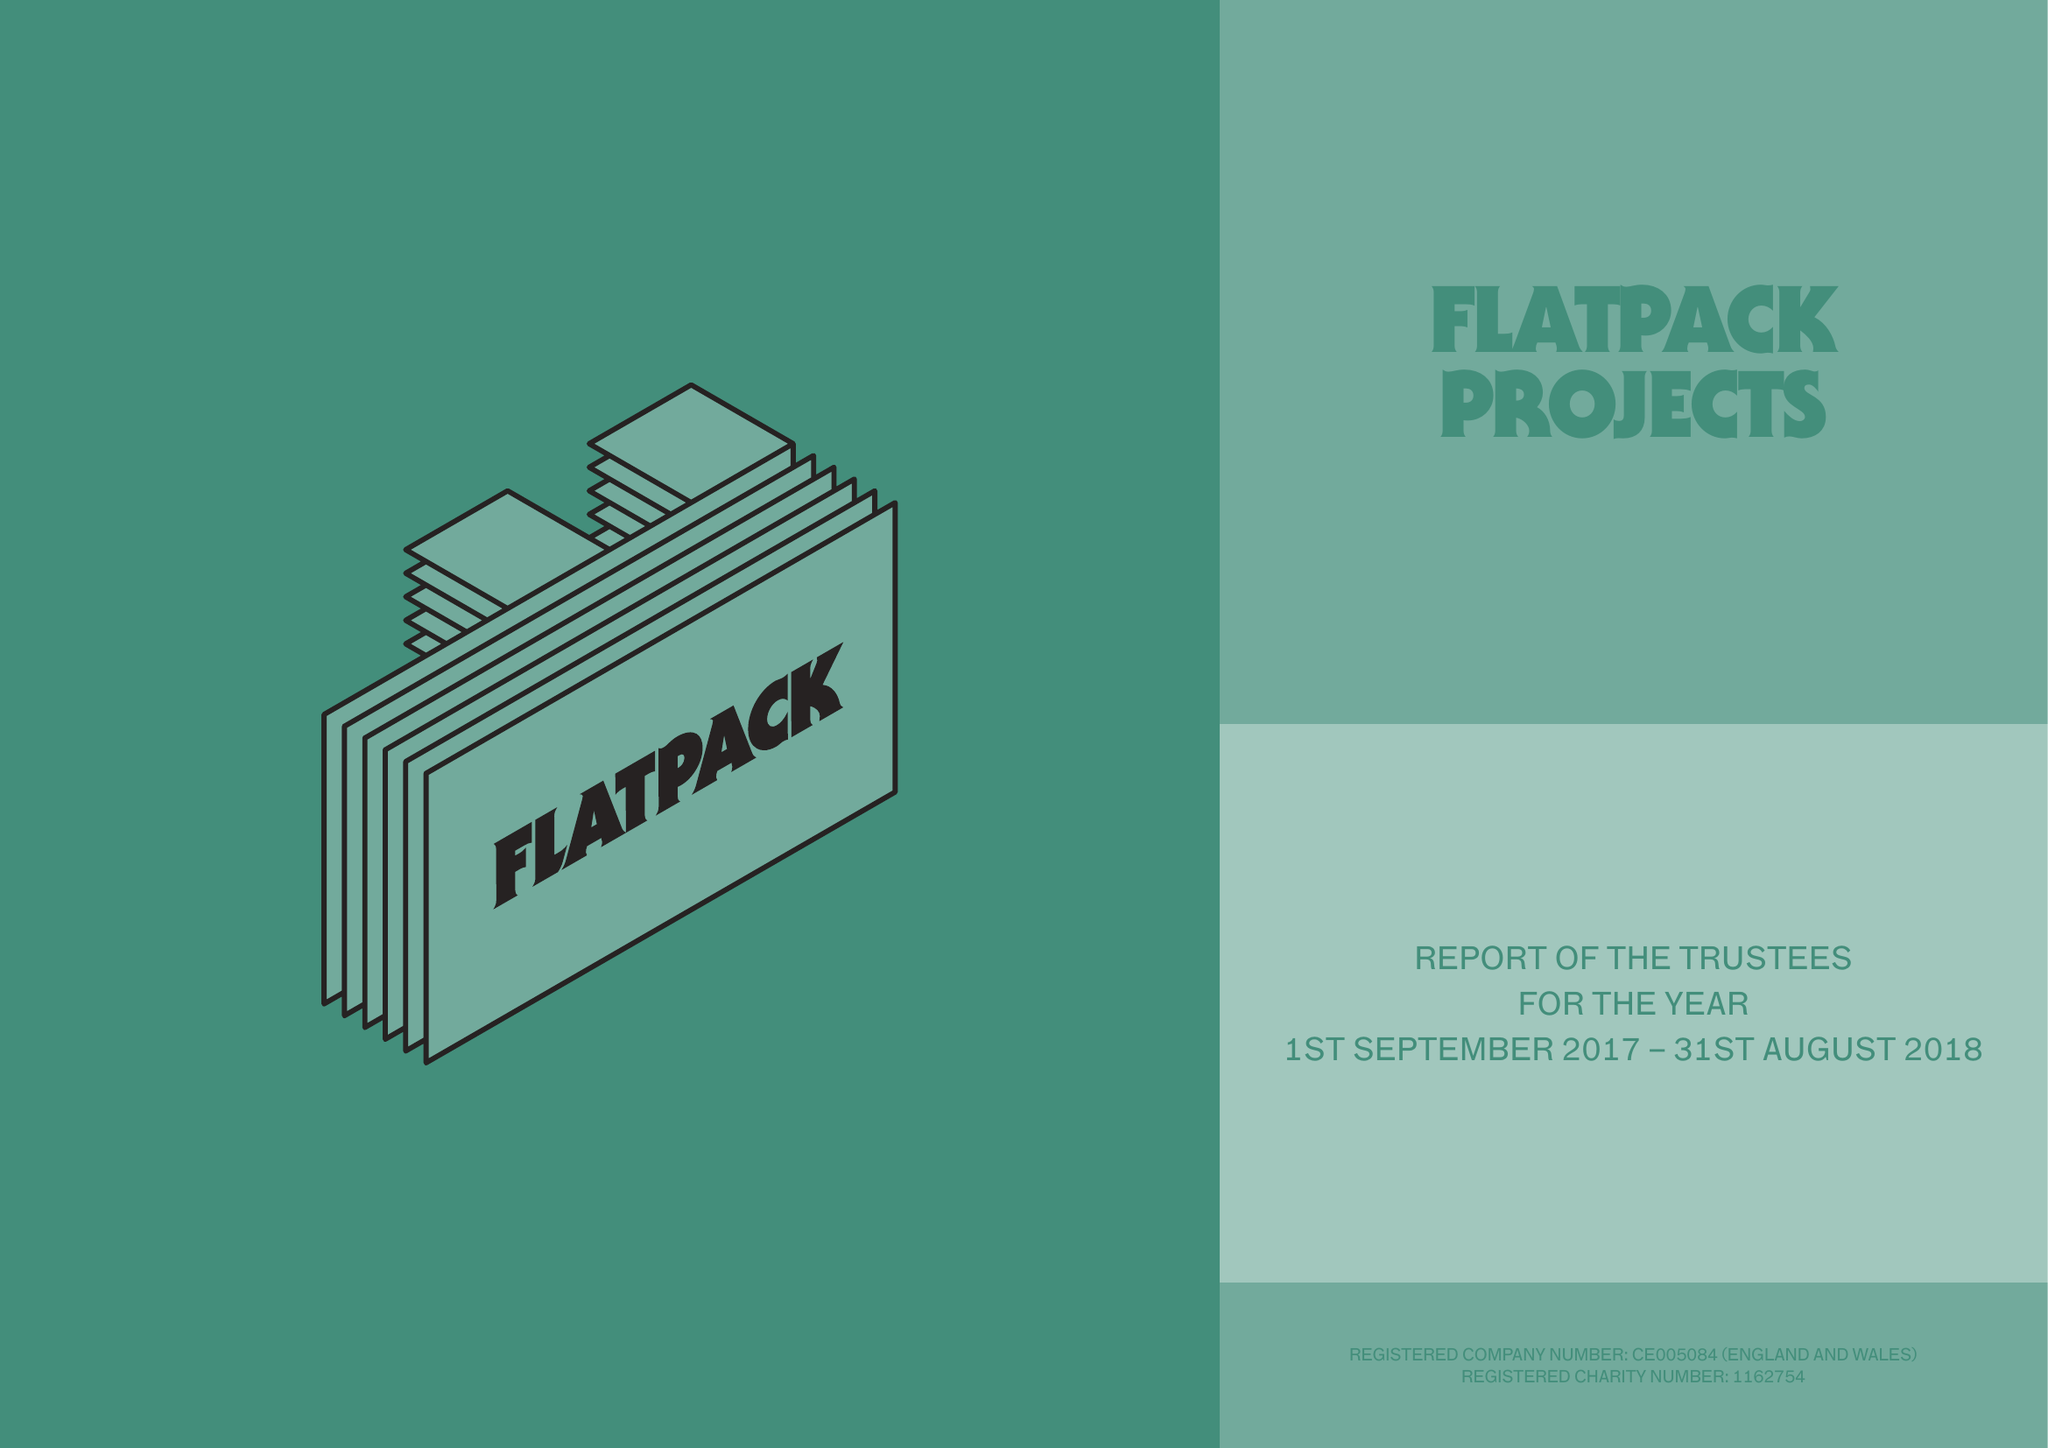What is the value for the charity_name?
Answer the question using a single word or phrase. Flatpack Projects 